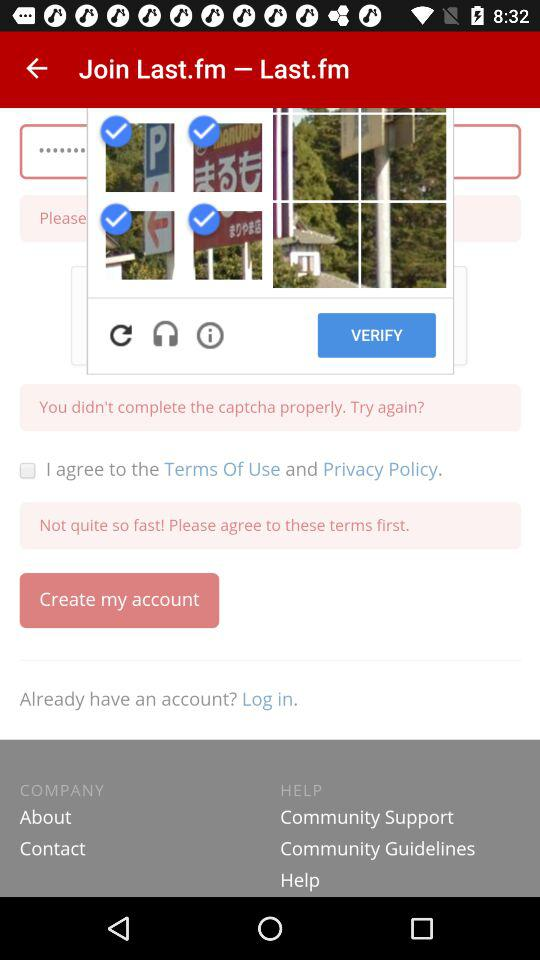What is the name of the application? The name of the application is "Last.fm". 